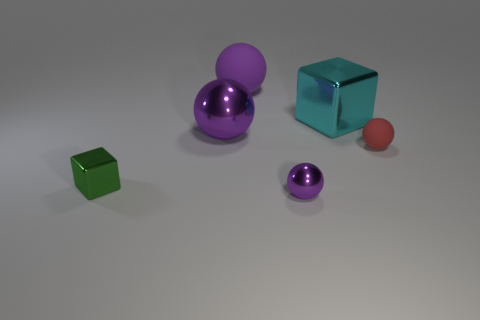Is the shape of the purple metal object that is in front of the green cube the same as the big matte thing that is left of the red object?
Ensure brevity in your answer.  Yes. There is a cyan metallic cube; how many metal objects are on the right side of it?
Make the answer very short. 0. What color is the rubber sphere left of the big cyan object?
Offer a terse response. Purple. There is a small metallic thing that is the same shape as the big cyan shiny thing; what is its color?
Your response must be concise. Green. Is there anything else that has the same color as the big block?
Keep it short and to the point. No. Is the number of big matte balls greater than the number of objects?
Make the answer very short. No. Are the small purple object and the green block made of the same material?
Ensure brevity in your answer.  Yes. How many small green things have the same material as the cyan thing?
Your response must be concise. 1. Is the size of the cyan object the same as the cube that is left of the cyan thing?
Give a very brief answer. No. The thing that is both in front of the red thing and to the right of the green object is what color?
Provide a succinct answer. Purple. 